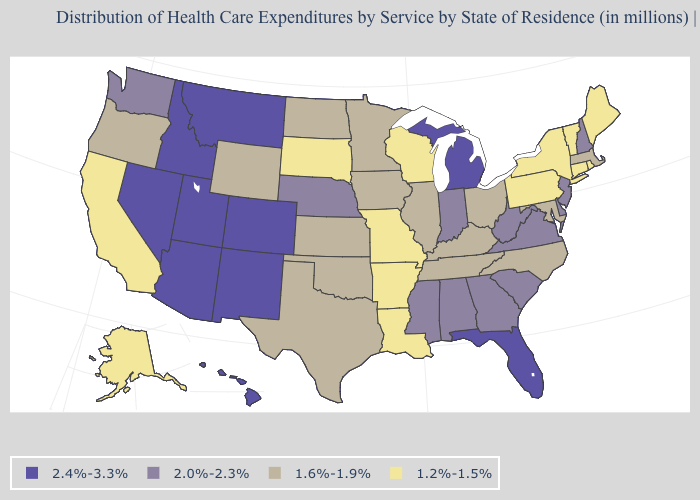Name the states that have a value in the range 1.6%-1.9%?
Keep it brief. Illinois, Iowa, Kansas, Kentucky, Maryland, Massachusetts, Minnesota, North Carolina, North Dakota, Ohio, Oklahoma, Oregon, Tennessee, Texas, Wyoming. Among the states that border Wyoming , does South Dakota have the lowest value?
Quick response, please. Yes. What is the value of South Carolina?
Short answer required. 2.0%-2.3%. What is the highest value in the MidWest ?
Concise answer only. 2.4%-3.3%. Name the states that have a value in the range 1.6%-1.9%?
Be succinct. Illinois, Iowa, Kansas, Kentucky, Maryland, Massachusetts, Minnesota, North Carolina, North Dakota, Ohio, Oklahoma, Oregon, Tennessee, Texas, Wyoming. Which states have the lowest value in the USA?
Concise answer only. Alaska, Arkansas, California, Connecticut, Louisiana, Maine, Missouri, New York, Pennsylvania, Rhode Island, South Dakota, Vermont, Wisconsin. Does Idaho have a lower value than Montana?
Be succinct. No. Does the map have missing data?
Be succinct. No. What is the value of New Jersey?
Concise answer only. 2.0%-2.3%. Among the states that border New Jersey , does Pennsylvania have the highest value?
Give a very brief answer. No. What is the value of Alaska?
Be succinct. 1.2%-1.5%. What is the value of South Carolina?
Short answer required. 2.0%-2.3%. Does Hawaii have the highest value in the USA?
Concise answer only. Yes. What is the value of Mississippi?
Be succinct. 2.0%-2.3%. Does Maryland have the highest value in the USA?
Quick response, please. No. 